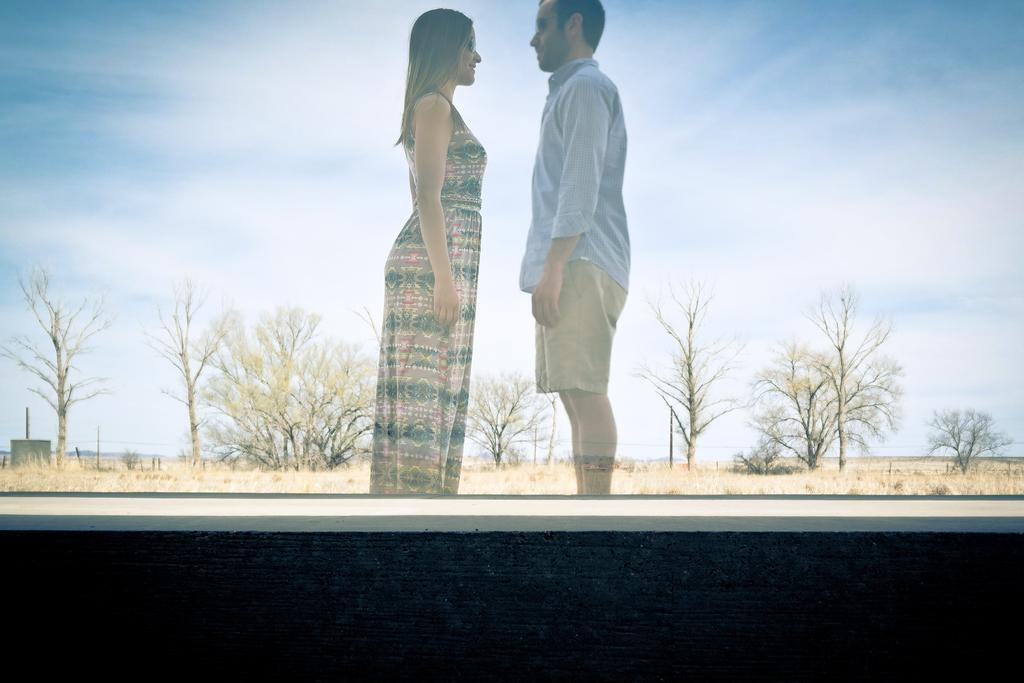How would you summarize this image in a sentence or two? In the picture I can see a couple standing on the ground. In the background, I can see the trees. There are clouds in the sky. 